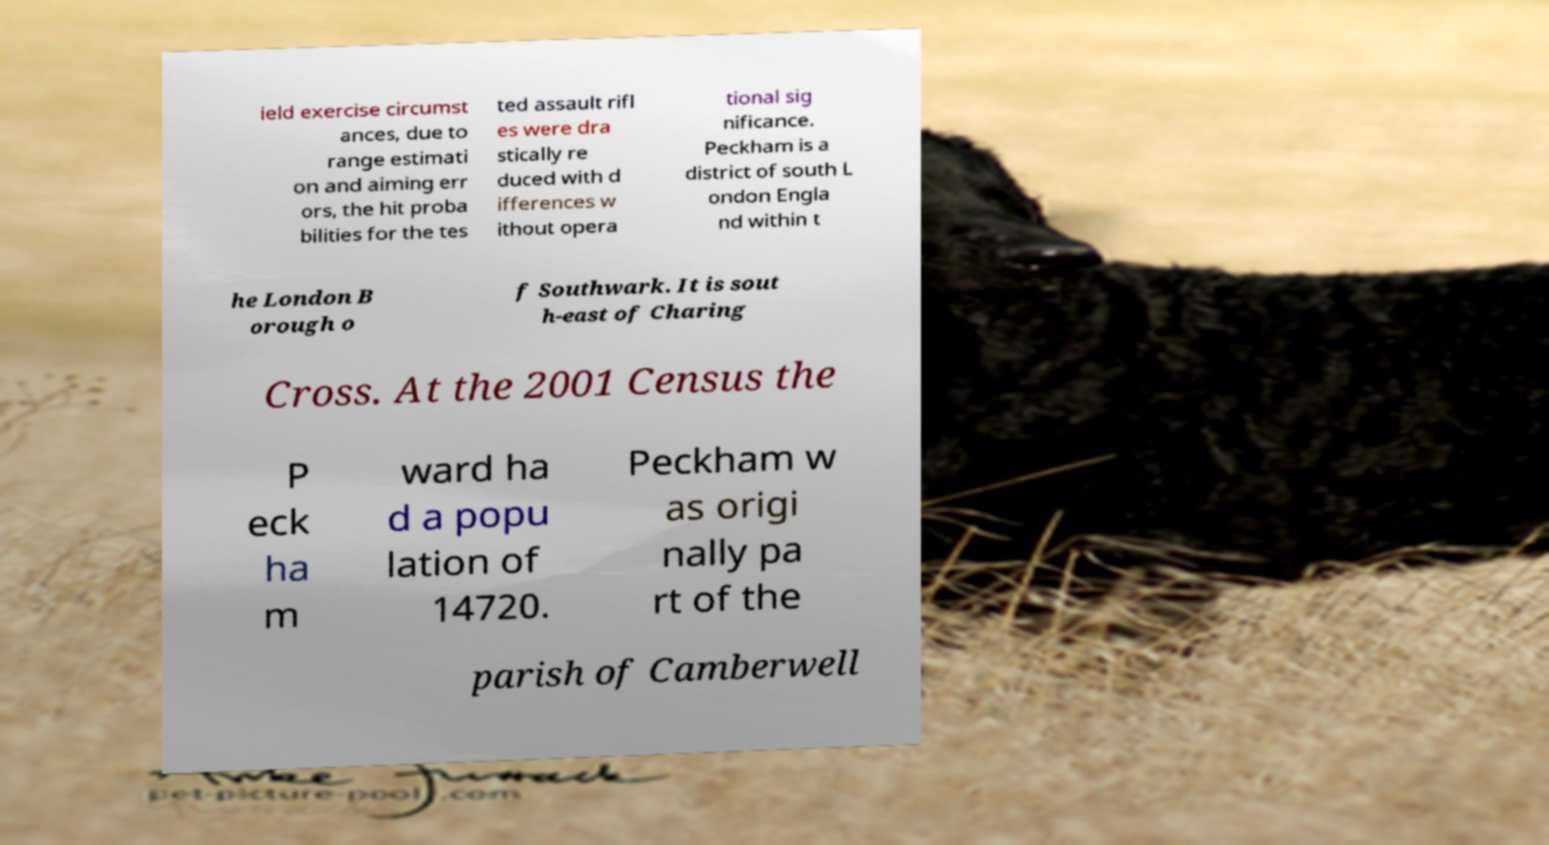Can you accurately transcribe the text from the provided image for me? ield exercise circumst ances, due to range estimati on and aiming err ors, the hit proba bilities for the tes ted assault rifl es were dra stically re duced with d ifferences w ithout opera tional sig nificance. Peckham is a district of south L ondon Engla nd within t he London B orough o f Southwark. It is sout h-east of Charing Cross. At the 2001 Census the P eck ha m ward ha d a popu lation of 14720. Peckham w as origi nally pa rt of the parish of Camberwell 